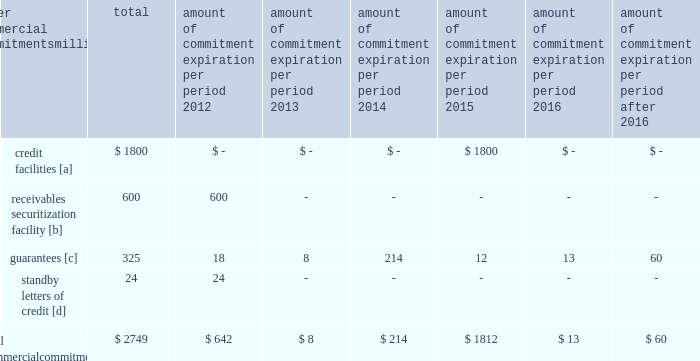Amount of commitment expiration per period other commercial commitments after millions total 2012 2013 2014 2015 2016 2016 .
[a] none of the credit facility was used as of december 31 , 2011 .
[b] $ 100 million of the receivables securitization facility was utilized at december 31 , 2011 , which is accounted for as debt .
The full program matures in august 2012 .
[c] includes guaranteed obligations related to our headquarters building , equipment financings , and affiliated operations .
[d] none of the letters of credit were drawn upon as of december 31 , 2011 .
Off-balance sheet arrangements guarantees 2013 at december 31 , 2011 , we were contingently liable for $ 325 million in guarantees .
We have recorded a liability of $ 3 million for the fair value of these obligations as of december 31 , 2011 and 2010 .
We entered into these contingent guarantees in the normal course of business , and they include guaranteed obligations related to our headquarters building , equipment financings , and affiliated operations .
The final guarantee expires in 2022 .
We are not aware of any existing event of default that would require us to satisfy these guarantees .
We do not expect that these guarantees will have a material adverse effect on our consolidated financial condition , results of operations , or liquidity .
Other matters labor agreements 2013 in january 2010 , the nation 2019s largest freight railroads began the current round of negotiations with the labor unions .
Generally , contract negotiations with the various unions take place over an extended period of time .
This round of negotiations was no exception .
In september 2011 , the rail industry reached agreements with the united transportation union .
On november 5 , 2011 , a presidential emergency board ( peb ) appointed by president obama issued recommendations to resolve the disputes between the u.s .
Railroads and 11 unions that had not yet reached agreements .
Since then , ten unions reached agreements with the railroads , all of them generally patterned on the recommendations of the peb , and the unions subsequently ratified these agreements .
The railroad industry reached a tentative agreement with the brotherhood of maintenance of way employees ( bmwe ) on february 2 , 2012 , eliminating the immediate threat of a national rail strike .
The bmwe now will commence ratification of this tentative agreement by its members .
Inflation 2013 long periods of inflation significantly increase asset replacement costs for capital-intensive companies .
As a result , assuming that we replace all operating assets at current price levels , depreciation charges ( on an inflation-adjusted basis ) would be substantially greater than historically reported amounts .
Derivative financial instruments 2013 we may use derivative financial instruments in limited instances to assist in managing our overall exposure to fluctuations in interest rates and fuel prices .
We are not a party to leveraged derivatives and , by policy , do not use derivative financial instruments for speculative purposes .
Derivative financial instruments qualifying for hedge accounting must maintain a specified level of effectiveness between the hedging instrument and the item being hedged , both at inception and throughout the hedged period .
We formally document the nature and relationships between the hedging instruments and hedged items at inception , as well as our risk-management objectives , strategies for undertaking the various hedge transactions , and method of assessing hedge effectiveness .
Changes in the fair market value of derivative financial instruments that do not qualify for hedge accounting are charged to earnings .
We may use swaps , collars , futures , and/or forward contracts to mitigate the risk of adverse movements in interest rates and fuel prices ; however , the use of these derivative financial instruments may limit future benefits from favorable price movements. .
Using the 2012 expirations as a guide , in how many years will the current commitments expire? 
Computations: (2749 / 642)
Answer: 4.28193. 